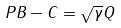Convert formula to latex. <formula><loc_0><loc_0><loc_500><loc_500>P B - C = \sqrt { \gamma } Q</formula> 